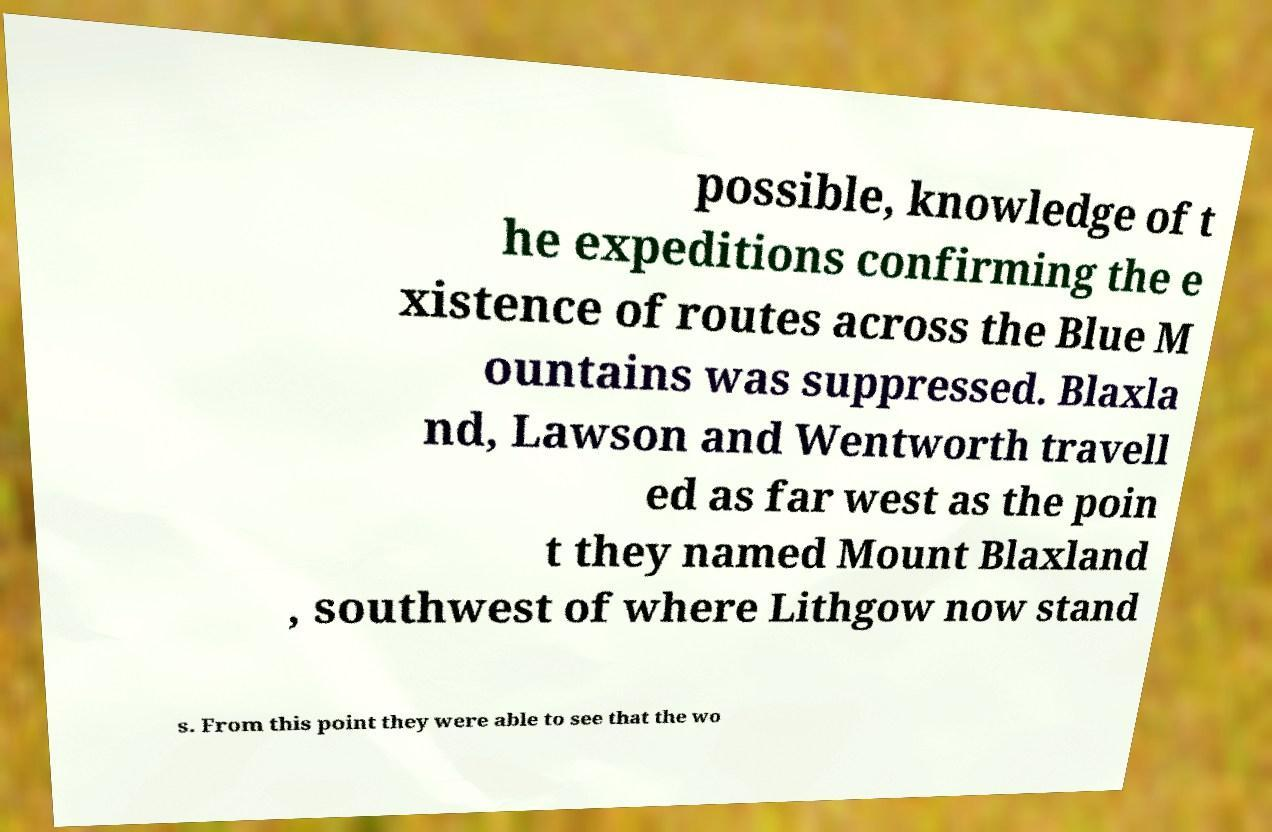For documentation purposes, I need the text within this image transcribed. Could you provide that? possible, knowledge of t he expeditions confirming the e xistence of routes across the Blue M ountains was suppressed. Blaxla nd, Lawson and Wentworth travell ed as far west as the poin t they named Mount Blaxland , southwest of where Lithgow now stand s. From this point they were able to see that the wo 